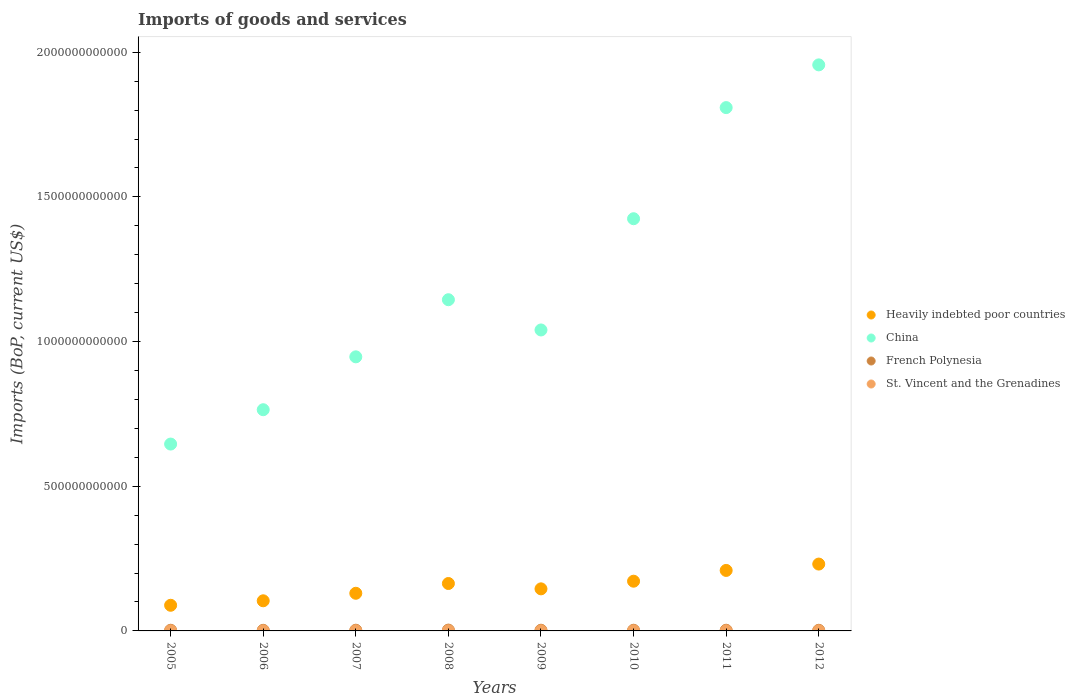What is the amount spent on imports in China in 2010?
Keep it short and to the point. 1.42e+12. Across all years, what is the maximum amount spent on imports in French Polynesia?
Offer a very short reply. 2.87e+09. Across all years, what is the minimum amount spent on imports in St. Vincent and the Grenadines?
Offer a very short reply. 2.91e+08. In which year was the amount spent on imports in China maximum?
Keep it short and to the point. 2012. What is the total amount spent on imports in St. Vincent and the Grenadines in the graph?
Ensure brevity in your answer.  3.01e+09. What is the difference between the amount spent on imports in St. Vincent and the Grenadines in 2009 and that in 2012?
Ensure brevity in your answer.  -1.41e+07. What is the difference between the amount spent on imports in China in 2006 and the amount spent on imports in St. Vincent and the Grenadines in 2012?
Provide a short and direct response. 7.64e+11. What is the average amount spent on imports in St. Vincent and the Grenadines per year?
Ensure brevity in your answer.  3.76e+08. In the year 2008, what is the difference between the amount spent on imports in Heavily indebted poor countries and amount spent on imports in China?
Your answer should be compact. -9.81e+11. What is the ratio of the amount spent on imports in China in 2005 to that in 2007?
Give a very brief answer. 0.68. What is the difference between the highest and the second highest amount spent on imports in China?
Keep it short and to the point. 1.48e+11. What is the difference between the highest and the lowest amount spent on imports in Heavily indebted poor countries?
Ensure brevity in your answer.  1.42e+11. In how many years, is the amount spent on imports in Heavily indebted poor countries greater than the average amount spent on imports in Heavily indebted poor countries taken over all years?
Offer a terse response. 4. Is the sum of the amount spent on imports in St. Vincent and the Grenadines in 2009 and 2012 greater than the maximum amount spent on imports in French Polynesia across all years?
Provide a succinct answer. No. Is it the case that in every year, the sum of the amount spent on imports in St. Vincent and the Grenadines and amount spent on imports in Heavily indebted poor countries  is greater than the sum of amount spent on imports in China and amount spent on imports in French Polynesia?
Keep it short and to the point. No. Is it the case that in every year, the sum of the amount spent on imports in St. Vincent and the Grenadines and amount spent on imports in Heavily indebted poor countries  is greater than the amount spent on imports in China?
Give a very brief answer. No. How many dotlines are there?
Keep it short and to the point. 4. How many years are there in the graph?
Provide a short and direct response. 8. What is the difference between two consecutive major ticks on the Y-axis?
Your response must be concise. 5.00e+11. Are the values on the major ticks of Y-axis written in scientific E-notation?
Give a very brief answer. No. Does the graph contain any zero values?
Your answer should be very brief. No. Does the graph contain grids?
Provide a succinct answer. No. Where does the legend appear in the graph?
Give a very brief answer. Center right. What is the title of the graph?
Your answer should be compact. Imports of goods and services. What is the label or title of the X-axis?
Provide a succinct answer. Years. What is the label or title of the Y-axis?
Your answer should be very brief. Imports (BoP, current US$). What is the Imports (BoP, current US$) of Heavily indebted poor countries in 2005?
Ensure brevity in your answer.  8.87e+1. What is the Imports (BoP, current US$) of China in 2005?
Provide a short and direct response. 6.46e+11. What is the Imports (BoP, current US$) in French Polynesia in 2005?
Your response must be concise. 2.31e+09. What is the Imports (BoP, current US$) of St. Vincent and the Grenadines in 2005?
Your answer should be compact. 2.91e+08. What is the Imports (BoP, current US$) of Heavily indebted poor countries in 2006?
Give a very brief answer. 1.04e+11. What is the Imports (BoP, current US$) in China in 2006?
Ensure brevity in your answer.  7.65e+11. What is the Imports (BoP, current US$) of French Polynesia in 2006?
Offer a terse response. 2.16e+09. What is the Imports (BoP, current US$) in St. Vincent and the Grenadines in 2006?
Provide a short and direct response. 3.26e+08. What is the Imports (BoP, current US$) in Heavily indebted poor countries in 2007?
Keep it short and to the point. 1.30e+11. What is the Imports (BoP, current US$) in China in 2007?
Your answer should be very brief. 9.47e+11. What is the Imports (BoP, current US$) of French Polynesia in 2007?
Offer a terse response. 2.43e+09. What is the Imports (BoP, current US$) in St. Vincent and the Grenadines in 2007?
Give a very brief answer. 4.02e+08. What is the Imports (BoP, current US$) in Heavily indebted poor countries in 2008?
Provide a succinct answer. 1.64e+11. What is the Imports (BoP, current US$) in China in 2008?
Your answer should be very brief. 1.14e+12. What is the Imports (BoP, current US$) of French Polynesia in 2008?
Provide a succinct answer. 2.87e+09. What is the Imports (BoP, current US$) of St. Vincent and the Grenadines in 2008?
Your response must be concise. 4.31e+08. What is the Imports (BoP, current US$) of Heavily indebted poor countries in 2009?
Provide a short and direct response. 1.45e+11. What is the Imports (BoP, current US$) in China in 2009?
Keep it short and to the point. 1.04e+12. What is the Imports (BoP, current US$) in French Polynesia in 2009?
Make the answer very short. 2.38e+09. What is the Imports (BoP, current US$) in St. Vincent and the Grenadines in 2009?
Offer a very short reply. 3.88e+08. What is the Imports (BoP, current US$) in Heavily indebted poor countries in 2010?
Keep it short and to the point. 1.72e+11. What is the Imports (BoP, current US$) of China in 2010?
Offer a terse response. 1.42e+12. What is the Imports (BoP, current US$) in French Polynesia in 2010?
Give a very brief answer. 2.33e+09. What is the Imports (BoP, current US$) of St. Vincent and the Grenadines in 2010?
Offer a terse response. 3.89e+08. What is the Imports (BoP, current US$) of Heavily indebted poor countries in 2011?
Make the answer very short. 2.09e+11. What is the Imports (BoP, current US$) of China in 2011?
Your answer should be very brief. 1.81e+12. What is the Imports (BoP, current US$) in French Polynesia in 2011?
Give a very brief answer. 2.34e+09. What is the Imports (BoP, current US$) in St. Vincent and the Grenadines in 2011?
Provide a succinct answer. 3.77e+08. What is the Imports (BoP, current US$) of Heavily indebted poor countries in 2012?
Your answer should be compact. 2.31e+11. What is the Imports (BoP, current US$) of China in 2012?
Make the answer very short. 1.96e+12. What is the Imports (BoP, current US$) of French Polynesia in 2012?
Your answer should be very brief. 2.20e+09. What is the Imports (BoP, current US$) in St. Vincent and the Grenadines in 2012?
Offer a very short reply. 4.02e+08. Across all years, what is the maximum Imports (BoP, current US$) of Heavily indebted poor countries?
Your response must be concise. 2.31e+11. Across all years, what is the maximum Imports (BoP, current US$) of China?
Your answer should be compact. 1.96e+12. Across all years, what is the maximum Imports (BoP, current US$) of French Polynesia?
Your answer should be very brief. 2.87e+09. Across all years, what is the maximum Imports (BoP, current US$) in St. Vincent and the Grenadines?
Keep it short and to the point. 4.31e+08. Across all years, what is the minimum Imports (BoP, current US$) of Heavily indebted poor countries?
Your response must be concise. 8.87e+1. Across all years, what is the minimum Imports (BoP, current US$) of China?
Your answer should be compact. 6.46e+11. Across all years, what is the minimum Imports (BoP, current US$) in French Polynesia?
Offer a very short reply. 2.16e+09. Across all years, what is the minimum Imports (BoP, current US$) of St. Vincent and the Grenadines?
Your response must be concise. 2.91e+08. What is the total Imports (BoP, current US$) in Heavily indebted poor countries in the graph?
Make the answer very short. 1.24e+12. What is the total Imports (BoP, current US$) of China in the graph?
Keep it short and to the point. 9.73e+12. What is the total Imports (BoP, current US$) in French Polynesia in the graph?
Ensure brevity in your answer.  1.90e+1. What is the total Imports (BoP, current US$) in St. Vincent and the Grenadines in the graph?
Your answer should be compact. 3.01e+09. What is the difference between the Imports (BoP, current US$) in Heavily indebted poor countries in 2005 and that in 2006?
Offer a very short reply. -1.55e+1. What is the difference between the Imports (BoP, current US$) in China in 2005 and that in 2006?
Your answer should be very brief. -1.19e+11. What is the difference between the Imports (BoP, current US$) in French Polynesia in 2005 and that in 2006?
Keep it short and to the point. 1.59e+08. What is the difference between the Imports (BoP, current US$) in St. Vincent and the Grenadines in 2005 and that in 2006?
Provide a short and direct response. -3.47e+07. What is the difference between the Imports (BoP, current US$) of Heavily indebted poor countries in 2005 and that in 2007?
Ensure brevity in your answer.  -4.14e+1. What is the difference between the Imports (BoP, current US$) in China in 2005 and that in 2007?
Provide a short and direct response. -3.01e+11. What is the difference between the Imports (BoP, current US$) of French Polynesia in 2005 and that in 2007?
Keep it short and to the point. -1.17e+08. What is the difference between the Imports (BoP, current US$) of St. Vincent and the Grenadines in 2005 and that in 2007?
Your answer should be very brief. -1.11e+08. What is the difference between the Imports (BoP, current US$) of Heavily indebted poor countries in 2005 and that in 2008?
Your response must be concise. -7.52e+1. What is the difference between the Imports (BoP, current US$) of China in 2005 and that in 2008?
Your answer should be compact. -4.99e+11. What is the difference between the Imports (BoP, current US$) of French Polynesia in 2005 and that in 2008?
Give a very brief answer. -5.50e+08. What is the difference between the Imports (BoP, current US$) in St. Vincent and the Grenadines in 2005 and that in 2008?
Offer a very short reply. -1.40e+08. What is the difference between the Imports (BoP, current US$) in Heavily indebted poor countries in 2005 and that in 2009?
Keep it short and to the point. -5.68e+1. What is the difference between the Imports (BoP, current US$) in China in 2005 and that in 2009?
Keep it short and to the point. -3.94e+11. What is the difference between the Imports (BoP, current US$) of French Polynesia in 2005 and that in 2009?
Your response must be concise. -6.25e+07. What is the difference between the Imports (BoP, current US$) of St. Vincent and the Grenadines in 2005 and that in 2009?
Keep it short and to the point. -9.69e+07. What is the difference between the Imports (BoP, current US$) in Heavily indebted poor countries in 2005 and that in 2010?
Your answer should be compact. -8.32e+1. What is the difference between the Imports (BoP, current US$) in China in 2005 and that in 2010?
Your answer should be very brief. -7.79e+11. What is the difference between the Imports (BoP, current US$) in French Polynesia in 2005 and that in 2010?
Make the answer very short. -1.53e+07. What is the difference between the Imports (BoP, current US$) of St. Vincent and the Grenadines in 2005 and that in 2010?
Offer a very short reply. -9.80e+07. What is the difference between the Imports (BoP, current US$) in Heavily indebted poor countries in 2005 and that in 2011?
Offer a terse response. -1.20e+11. What is the difference between the Imports (BoP, current US$) in China in 2005 and that in 2011?
Your response must be concise. -1.16e+12. What is the difference between the Imports (BoP, current US$) in French Polynesia in 2005 and that in 2011?
Your response must be concise. -2.05e+07. What is the difference between the Imports (BoP, current US$) in St. Vincent and the Grenadines in 2005 and that in 2011?
Offer a very short reply. -8.54e+07. What is the difference between the Imports (BoP, current US$) in Heavily indebted poor countries in 2005 and that in 2012?
Your answer should be very brief. -1.42e+11. What is the difference between the Imports (BoP, current US$) of China in 2005 and that in 2012?
Keep it short and to the point. -1.31e+12. What is the difference between the Imports (BoP, current US$) of French Polynesia in 2005 and that in 2012?
Offer a very short reply. 1.11e+08. What is the difference between the Imports (BoP, current US$) in St. Vincent and the Grenadines in 2005 and that in 2012?
Your answer should be compact. -1.11e+08. What is the difference between the Imports (BoP, current US$) in Heavily indebted poor countries in 2006 and that in 2007?
Ensure brevity in your answer.  -2.60e+1. What is the difference between the Imports (BoP, current US$) of China in 2006 and that in 2007?
Keep it short and to the point. -1.83e+11. What is the difference between the Imports (BoP, current US$) in French Polynesia in 2006 and that in 2007?
Provide a short and direct response. -2.76e+08. What is the difference between the Imports (BoP, current US$) in St. Vincent and the Grenadines in 2006 and that in 2007?
Ensure brevity in your answer.  -7.63e+07. What is the difference between the Imports (BoP, current US$) in Heavily indebted poor countries in 2006 and that in 2008?
Offer a terse response. -5.98e+1. What is the difference between the Imports (BoP, current US$) in China in 2006 and that in 2008?
Ensure brevity in your answer.  -3.80e+11. What is the difference between the Imports (BoP, current US$) in French Polynesia in 2006 and that in 2008?
Provide a succinct answer. -7.10e+08. What is the difference between the Imports (BoP, current US$) of St. Vincent and the Grenadines in 2006 and that in 2008?
Keep it short and to the point. -1.05e+08. What is the difference between the Imports (BoP, current US$) in Heavily indebted poor countries in 2006 and that in 2009?
Offer a terse response. -4.13e+1. What is the difference between the Imports (BoP, current US$) of China in 2006 and that in 2009?
Make the answer very short. -2.76e+11. What is the difference between the Imports (BoP, current US$) in French Polynesia in 2006 and that in 2009?
Ensure brevity in your answer.  -2.22e+08. What is the difference between the Imports (BoP, current US$) of St. Vincent and the Grenadines in 2006 and that in 2009?
Keep it short and to the point. -6.22e+07. What is the difference between the Imports (BoP, current US$) of Heavily indebted poor countries in 2006 and that in 2010?
Your answer should be very brief. -6.77e+1. What is the difference between the Imports (BoP, current US$) in China in 2006 and that in 2010?
Keep it short and to the point. -6.60e+11. What is the difference between the Imports (BoP, current US$) of French Polynesia in 2006 and that in 2010?
Your answer should be compact. -1.75e+08. What is the difference between the Imports (BoP, current US$) in St. Vincent and the Grenadines in 2006 and that in 2010?
Provide a short and direct response. -6.33e+07. What is the difference between the Imports (BoP, current US$) in Heavily indebted poor countries in 2006 and that in 2011?
Provide a succinct answer. -1.05e+11. What is the difference between the Imports (BoP, current US$) in China in 2006 and that in 2011?
Your answer should be compact. -1.04e+12. What is the difference between the Imports (BoP, current US$) in French Polynesia in 2006 and that in 2011?
Provide a short and direct response. -1.80e+08. What is the difference between the Imports (BoP, current US$) of St. Vincent and the Grenadines in 2006 and that in 2011?
Give a very brief answer. -5.08e+07. What is the difference between the Imports (BoP, current US$) of Heavily indebted poor countries in 2006 and that in 2012?
Your answer should be very brief. -1.27e+11. What is the difference between the Imports (BoP, current US$) of China in 2006 and that in 2012?
Make the answer very short. -1.19e+12. What is the difference between the Imports (BoP, current US$) in French Polynesia in 2006 and that in 2012?
Provide a succinct answer. -4.88e+07. What is the difference between the Imports (BoP, current US$) of St. Vincent and the Grenadines in 2006 and that in 2012?
Your answer should be very brief. -7.62e+07. What is the difference between the Imports (BoP, current US$) of Heavily indebted poor countries in 2007 and that in 2008?
Provide a short and direct response. -3.38e+1. What is the difference between the Imports (BoP, current US$) of China in 2007 and that in 2008?
Offer a very short reply. -1.97e+11. What is the difference between the Imports (BoP, current US$) of French Polynesia in 2007 and that in 2008?
Provide a short and direct response. -4.33e+08. What is the difference between the Imports (BoP, current US$) of St. Vincent and the Grenadines in 2007 and that in 2008?
Offer a terse response. -2.87e+07. What is the difference between the Imports (BoP, current US$) in Heavily indebted poor countries in 2007 and that in 2009?
Provide a succinct answer. -1.53e+1. What is the difference between the Imports (BoP, current US$) in China in 2007 and that in 2009?
Your answer should be very brief. -9.29e+1. What is the difference between the Imports (BoP, current US$) in French Polynesia in 2007 and that in 2009?
Give a very brief answer. 5.44e+07. What is the difference between the Imports (BoP, current US$) in St. Vincent and the Grenadines in 2007 and that in 2009?
Your answer should be very brief. 1.41e+07. What is the difference between the Imports (BoP, current US$) in Heavily indebted poor countries in 2007 and that in 2010?
Offer a terse response. -4.17e+1. What is the difference between the Imports (BoP, current US$) in China in 2007 and that in 2010?
Give a very brief answer. -4.77e+11. What is the difference between the Imports (BoP, current US$) of French Polynesia in 2007 and that in 2010?
Provide a short and direct response. 1.02e+08. What is the difference between the Imports (BoP, current US$) of St. Vincent and the Grenadines in 2007 and that in 2010?
Provide a succinct answer. 1.29e+07. What is the difference between the Imports (BoP, current US$) of Heavily indebted poor countries in 2007 and that in 2011?
Your answer should be very brief. -7.90e+1. What is the difference between the Imports (BoP, current US$) of China in 2007 and that in 2011?
Give a very brief answer. -8.61e+11. What is the difference between the Imports (BoP, current US$) in French Polynesia in 2007 and that in 2011?
Keep it short and to the point. 9.64e+07. What is the difference between the Imports (BoP, current US$) in St. Vincent and the Grenadines in 2007 and that in 2011?
Provide a short and direct response. 2.55e+07. What is the difference between the Imports (BoP, current US$) in Heavily indebted poor countries in 2007 and that in 2012?
Make the answer very short. -1.01e+11. What is the difference between the Imports (BoP, current US$) of China in 2007 and that in 2012?
Ensure brevity in your answer.  -1.01e+12. What is the difference between the Imports (BoP, current US$) of French Polynesia in 2007 and that in 2012?
Give a very brief answer. 2.27e+08. What is the difference between the Imports (BoP, current US$) of St. Vincent and the Grenadines in 2007 and that in 2012?
Offer a very short reply. 1.83e+04. What is the difference between the Imports (BoP, current US$) of Heavily indebted poor countries in 2008 and that in 2009?
Offer a terse response. 1.85e+1. What is the difference between the Imports (BoP, current US$) in China in 2008 and that in 2009?
Provide a short and direct response. 1.05e+11. What is the difference between the Imports (BoP, current US$) of French Polynesia in 2008 and that in 2009?
Offer a very short reply. 4.88e+08. What is the difference between the Imports (BoP, current US$) in St. Vincent and the Grenadines in 2008 and that in 2009?
Offer a terse response. 4.28e+07. What is the difference between the Imports (BoP, current US$) in Heavily indebted poor countries in 2008 and that in 2010?
Provide a short and direct response. -7.95e+09. What is the difference between the Imports (BoP, current US$) of China in 2008 and that in 2010?
Your answer should be very brief. -2.80e+11. What is the difference between the Imports (BoP, current US$) in French Polynesia in 2008 and that in 2010?
Make the answer very short. 5.35e+08. What is the difference between the Imports (BoP, current US$) in St. Vincent and the Grenadines in 2008 and that in 2010?
Offer a terse response. 4.16e+07. What is the difference between the Imports (BoP, current US$) in Heavily indebted poor countries in 2008 and that in 2011?
Give a very brief answer. -4.52e+1. What is the difference between the Imports (BoP, current US$) of China in 2008 and that in 2011?
Your answer should be compact. -6.64e+11. What is the difference between the Imports (BoP, current US$) in French Polynesia in 2008 and that in 2011?
Ensure brevity in your answer.  5.30e+08. What is the difference between the Imports (BoP, current US$) of St. Vincent and the Grenadines in 2008 and that in 2011?
Offer a very short reply. 5.42e+07. What is the difference between the Imports (BoP, current US$) in Heavily indebted poor countries in 2008 and that in 2012?
Provide a succinct answer. -6.72e+1. What is the difference between the Imports (BoP, current US$) in China in 2008 and that in 2012?
Make the answer very short. -8.12e+11. What is the difference between the Imports (BoP, current US$) in French Polynesia in 2008 and that in 2012?
Ensure brevity in your answer.  6.61e+08. What is the difference between the Imports (BoP, current US$) of St. Vincent and the Grenadines in 2008 and that in 2012?
Your answer should be compact. 2.87e+07. What is the difference between the Imports (BoP, current US$) of Heavily indebted poor countries in 2009 and that in 2010?
Provide a short and direct response. -2.64e+1. What is the difference between the Imports (BoP, current US$) in China in 2009 and that in 2010?
Ensure brevity in your answer.  -3.84e+11. What is the difference between the Imports (BoP, current US$) of French Polynesia in 2009 and that in 2010?
Offer a very short reply. 4.72e+07. What is the difference between the Imports (BoP, current US$) of St. Vincent and the Grenadines in 2009 and that in 2010?
Your answer should be compact. -1.13e+06. What is the difference between the Imports (BoP, current US$) in Heavily indebted poor countries in 2009 and that in 2011?
Provide a short and direct response. -6.37e+1. What is the difference between the Imports (BoP, current US$) in China in 2009 and that in 2011?
Ensure brevity in your answer.  -7.69e+11. What is the difference between the Imports (BoP, current US$) of French Polynesia in 2009 and that in 2011?
Make the answer very short. 4.20e+07. What is the difference between the Imports (BoP, current US$) in St. Vincent and the Grenadines in 2009 and that in 2011?
Give a very brief answer. 1.14e+07. What is the difference between the Imports (BoP, current US$) of Heavily indebted poor countries in 2009 and that in 2012?
Keep it short and to the point. -8.56e+1. What is the difference between the Imports (BoP, current US$) of China in 2009 and that in 2012?
Offer a terse response. -9.16e+11. What is the difference between the Imports (BoP, current US$) of French Polynesia in 2009 and that in 2012?
Your answer should be very brief. 1.73e+08. What is the difference between the Imports (BoP, current US$) in St. Vincent and the Grenadines in 2009 and that in 2012?
Your response must be concise. -1.41e+07. What is the difference between the Imports (BoP, current US$) in Heavily indebted poor countries in 2010 and that in 2011?
Your answer should be compact. -3.72e+1. What is the difference between the Imports (BoP, current US$) in China in 2010 and that in 2011?
Your answer should be very brief. -3.84e+11. What is the difference between the Imports (BoP, current US$) in French Polynesia in 2010 and that in 2011?
Your answer should be compact. -5.19e+06. What is the difference between the Imports (BoP, current US$) in St. Vincent and the Grenadines in 2010 and that in 2011?
Offer a very short reply. 1.26e+07. What is the difference between the Imports (BoP, current US$) of Heavily indebted poor countries in 2010 and that in 2012?
Make the answer very short. -5.92e+1. What is the difference between the Imports (BoP, current US$) in China in 2010 and that in 2012?
Your answer should be compact. -5.32e+11. What is the difference between the Imports (BoP, current US$) in French Polynesia in 2010 and that in 2012?
Your answer should be compact. 1.26e+08. What is the difference between the Imports (BoP, current US$) of St. Vincent and the Grenadines in 2010 and that in 2012?
Offer a terse response. -1.29e+07. What is the difference between the Imports (BoP, current US$) in Heavily indebted poor countries in 2011 and that in 2012?
Your answer should be compact. -2.20e+1. What is the difference between the Imports (BoP, current US$) in China in 2011 and that in 2012?
Give a very brief answer. -1.48e+11. What is the difference between the Imports (BoP, current US$) of French Polynesia in 2011 and that in 2012?
Offer a very short reply. 1.31e+08. What is the difference between the Imports (BoP, current US$) in St. Vincent and the Grenadines in 2011 and that in 2012?
Your answer should be very brief. -2.55e+07. What is the difference between the Imports (BoP, current US$) in Heavily indebted poor countries in 2005 and the Imports (BoP, current US$) in China in 2006?
Keep it short and to the point. -6.76e+11. What is the difference between the Imports (BoP, current US$) of Heavily indebted poor countries in 2005 and the Imports (BoP, current US$) of French Polynesia in 2006?
Keep it short and to the point. 8.65e+1. What is the difference between the Imports (BoP, current US$) of Heavily indebted poor countries in 2005 and the Imports (BoP, current US$) of St. Vincent and the Grenadines in 2006?
Your answer should be very brief. 8.83e+1. What is the difference between the Imports (BoP, current US$) of China in 2005 and the Imports (BoP, current US$) of French Polynesia in 2006?
Offer a terse response. 6.44e+11. What is the difference between the Imports (BoP, current US$) of China in 2005 and the Imports (BoP, current US$) of St. Vincent and the Grenadines in 2006?
Provide a succinct answer. 6.46e+11. What is the difference between the Imports (BoP, current US$) in French Polynesia in 2005 and the Imports (BoP, current US$) in St. Vincent and the Grenadines in 2006?
Give a very brief answer. 1.99e+09. What is the difference between the Imports (BoP, current US$) in Heavily indebted poor countries in 2005 and the Imports (BoP, current US$) in China in 2007?
Your answer should be very brief. -8.59e+11. What is the difference between the Imports (BoP, current US$) of Heavily indebted poor countries in 2005 and the Imports (BoP, current US$) of French Polynesia in 2007?
Offer a terse response. 8.62e+1. What is the difference between the Imports (BoP, current US$) of Heavily indebted poor countries in 2005 and the Imports (BoP, current US$) of St. Vincent and the Grenadines in 2007?
Ensure brevity in your answer.  8.82e+1. What is the difference between the Imports (BoP, current US$) of China in 2005 and the Imports (BoP, current US$) of French Polynesia in 2007?
Your response must be concise. 6.43e+11. What is the difference between the Imports (BoP, current US$) of China in 2005 and the Imports (BoP, current US$) of St. Vincent and the Grenadines in 2007?
Make the answer very short. 6.45e+11. What is the difference between the Imports (BoP, current US$) in French Polynesia in 2005 and the Imports (BoP, current US$) in St. Vincent and the Grenadines in 2007?
Offer a very short reply. 1.91e+09. What is the difference between the Imports (BoP, current US$) in Heavily indebted poor countries in 2005 and the Imports (BoP, current US$) in China in 2008?
Provide a short and direct response. -1.06e+12. What is the difference between the Imports (BoP, current US$) of Heavily indebted poor countries in 2005 and the Imports (BoP, current US$) of French Polynesia in 2008?
Offer a terse response. 8.58e+1. What is the difference between the Imports (BoP, current US$) of Heavily indebted poor countries in 2005 and the Imports (BoP, current US$) of St. Vincent and the Grenadines in 2008?
Your answer should be compact. 8.82e+1. What is the difference between the Imports (BoP, current US$) in China in 2005 and the Imports (BoP, current US$) in French Polynesia in 2008?
Provide a short and direct response. 6.43e+11. What is the difference between the Imports (BoP, current US$) in China in 2005 and the Imports (BoP, current US$) in St. Vincent and the Grenadines in 2008?
Ensure brevity in your answer.  6.45e+11. What is the difference between the Imports (BoP, current US$) in French Polynesia in 2005 and the Imports (BoP, current US$) in St. Vincent and the Grenadines in 2008?
Offer a very short reply. 1.88e+09. What is the difference between the Imports (BoP, current US$) in Heavily indebted poor countries in 2005 and the Imports (BoP, current US$) in China in 2009?
Your answer should be compact. -9.52e+11. What is the difference between the Imports (BoP, current US$) of Heavily indebted poor countries in 2005 and the Imports (BoP, current US$) of French Polynesia in 2009?
Give a very brief answer. 8.63e+1. What is the difference between the Imports (BoP, current US$) in Heavily indebted poor countries in 2005 and the Imports (BoP, current US$) in St. Vincent and the Grenadines in 2009?
Keep it short and to the point. 8.83e+1. What is the difference between the Imports (BoP, current US$) of China in 2005 and the Imports (BoP, current US$) of French Polynesia in 2009?
Make the answer very short. 6.43e+11. What is the difference between the Imports (BoP, current US$) in China in 2005 and the Imports (BoP, current US$) in St. Vincent and the Grenadines in 2009?
Give a very brief answer. 6.45e+11. What is the difference between the Imports (BoP, current US$) of French Polynesia in 2005 and the Imports (BoP, current US$) of St. Vincent and the Grenadines in 2009?
Offer a very short reply. 1.93e+09. What is the difference between the Imports (BoP, current US$) of Heavily indebted poor countries in 2005 and the Imports (BoP, current US$) of China in 2010?
Ensure brevity in your answer.  -1.34e+12. What is the difference between the Imports (BoP, current US$) of Heavily indebted poor countries in 2005 and the Imports (BoP, current US$) of French Polynesia in 2010?
Your response must be concise. 8.63e+1. What is the difference between the Imports (BoP, current US$) in Heavily indebted poor countries in 2005 and the Imports (BoP, current US$) in St. Vincent and the Grenadines in 2010?
Make the answer very short. 8.83e+1. What is the difference between the Imports (BoP, current US$) of China in 2005 and the Imports (BoP, current US$) of French Polynesia in 2010?
Your response must be concise. 6.44e+11. What is the difference between the Imports (BoP, current US$) in China in 2005 and the Imports (BoP, current US$) in St. Vincent and the Grenadines in 2010?
Provide a short and direct response. 6.45e+11. What is the difference between the Imports (BoP, current US$) in French Polynesia in 2005 and the Imports (BoP, current US$) in St. Vincent and the Grenadines in 2010?
Ensure brevity in your answer.  1.93e+09. What is the difference between the Imports (BoP, current US$) in Heavily indebted poor countries in 2005 and the Imports (BoP, current US$) in China in 2011?
Give a very brief answer. -1.72e+12. What is the difference between the Imports (BoP, current US$) of Heavily indebted poor countries in 2005 and the Imports (BoP, current US$) of French Polynesia in 2011?
Offer a very short reply. 8.63e+1. What is the difference between the Imports (BoP, current US$) in Heavily indebted poor countries in 2005 and the Imports (BoP, current US$) in St. Vincent and the Grenadines in 2011?
Give a very brief answer. 8.83e+1. What is the difference between the Imports (BoP, current US$) in China in 2005 and the Imports (BoP, current US$) in French Polynesia in 2011?
Your answer should be very brief. 6.43e+11. What is the difference between the Imports (BoP, current US$) of China in 2005 and the Imports (BoP, current US$) of St. Vincent and the Grenadines in 2011?
Offer a very short reply. 6.45e+11. What is the difference between the Imports (BoP, current US$) of French Polynesia in 2005 and the Imports (BoP, current US$) of St. Vincent and the Grenadines in 2011?
Your answer should be compact. 1.94e+09. What is the difference between the Imports (BoP, current US$) of Heavily indebted poor countries in 2005 and the Imports (BoP, current US$) of China in 2012?
Your answer should be very brief. -1.87e+12. What is the difference between the Imports (BoP, current US$) in Heavily indebted poor countries in 2005 and the Imports (BoP, current US$) in French Polynesia in 2012?
Provide a succinct answer. 8.64e+1. What is the difference between the Imports (BoP, current US$) of Heavily indebted poor countries in 2005 and the Imports (BoP, current US$) of St. Vincent and the Grenadines in 2012?
Offer a very short reply. 8.82e+1. What is the difference between the Imports (BoP, current US$) of China in 2005 and the Imports (BoP, current US$) of French Polynesia in 2012?
Your answer should be very brief. 6.44e+11. What is the difference between the Imports (BoP, current US$) in China in 2005 and the Imports (BoP, current US$) in St. Vincent and the Grenadines in 2012?
Your response must be concise. 6.45e+11. What is the difference between the Imports (BoP, current US$) of French Polynesia in 2005 and the Imports (BoP, current US$) of St. Vincent and the Grenadines in 2012?
Offer a terse response. 1.91e+09. What is the difference between the Imports (BoP, current US$) of Heavily indebted poor countries in 2006 and the Imports (BoP, current US$) of China in 2007?
Make the answer very short. -8.43e+11. What is the difference between the Imports (BoP, current US$) of Heavily indebted poor countries in 2006 and the Imports (BoP, current US$) of French Polynesia in 2007?
Make the answer very short. 1.02e+11. What is the difference between the Imports (BoP, current US$) of Heavily indebted poor countries in 2006 and the Imports (BoP, current US$) of St. Vincent and the Grenadines in 2007?
Ensure brevity in your answer.  1.04e+11. What is the difference between the Imports (BoP, current US$) of China in 2006 and the Imports (BoP, current US$) of French Polynesia in 2007?
Offer a very short reply. 7.62e+11. What is the difference between the Imports (BoP, current US$) of China in 2006 and the Imports (BoP, current US$) of St. Vincent and the Grenadines in 2007?
Provide a succinct answer. 7.64e+11. What is the difference between the Imports (BoP, current US$) in French Polynesia in 2006 and the Imports (BoP, current US$) in St. Vincent and the Grenadines in 2007?
Offer a very short reply. 1.75e+09. What is the difference between the Imports (BoP, current US$) in Heavily indebted poor countries in 2006 and the Imports (BoP, current US$) in China in 2008?
Your answer should be compact. -1.04e+12. What is the difference between the Imports (BoP, current US$) in Heavily indebted poor countries in 2006 and the Imports (BoP, current US$) in French Polynesia in 2008?
Make the answer very short. 1.01e+11. What is the difference between the Imports (BoP, current US$) in Heavily indebted poor countries in 2006 and the Imports (BoP, current US$) in St. Vincent and the Grenadines in 2008?
Your answer should be very brief. 1.04e+11. What is the difference between the Imports (BoP, current US$) of China in 2006 and the Imports (BoP, current US$) of French Polynesia in 2008?
Your response must be concise. 7.62e+11. What is the difference between the Imports (BoP, current US$) in China in 2006 and the Imports (BoP, current US$) in St. Vincent and the Grenadines in 2008?
Keep it short and to the point. 7.64e+11. What is the difference between the Imports (BoP, current US$) of French Polynesia in 2006 and the Imports (BoP, current US$) of St. Vincent and the Grenadines in 2008?
Provide a succinct answer. 1.72e+09. What is the difference between the Imports (BoP, current US$) in Heavily indebted poor countries in 2006 and the Imports (BoP, current US$) in China in 2009?
Your answer should be very brief. -9.36e+11. What is the difference between the Imports (BoP, current US$) in Heavily indebted poor countries in 2006 and the Imports (BoP, current US$) in French Polynesia in 2009?
Provide a succinct answer. 1.02e+11. What is the difference between the Imports (BoP, current US$) in Heavily indebted poor countries in 2006 and the Imports (BoP, current US$) in St. Vincent and the Grenadines in 2009?
Your answer should be compact. 1.04e+11. What is the difference between the Imports (BoP, current US$) of China in 2006 and the Imports (BoP, current US$) of French Polynesia in 2009?
Your answer should be compact. 7.62e+11. What is the difference between the Imports (BoP, current US$) in China in 2006 and the Imports (BoP, current US$) in St. Vincent and the Grenadines in 2009?
Ensure brevity in your answer.  7.64e+11. What is the difference between the Imports (BoP, current US$) of French Polynesia in 2006 and the Imports (BoP, current US$) of St. Vincent and the Grenadines in 2009?
Give a very brief answer. 1.77e+09. What is the difference between the Imports (BoP, current US$) in Heavily indebted poor countries in 2006 and the Imports (BoP, current US$) in China in 2010?
Your answer should be compact. -1.32e+12. What is the difference between the Imports (BoP, current US$) of Heavily indebted poor countries in 2006 and the Imports (BoP, current US$) of French Polynesia in 2010?
Offer a terse response. 1.02e+11. What is the difference between the Imports (BoP, current US$) in Heavily indebted poor countries in 2006 and the Imports (BoP, current US$) in St. Vincent and the Grenadines in 2010?
Your answer should be very brief. 1.04e+11. What is the difference between the Imports (BoP, current US$) of China in 2006 and the Imports (BoP, current US$) of French Polynesia in 2010?
Keep it short and to the point. 7.62e+11. What is the difference between the Imports (BoP, current US$) in China in 2006 and the Imports (BoP, current US$) in St. Vincent and the Grenadines in 2010?
Provide a short and direct response. 7.64e+11. What is the difference between the Imports (BoP, current US$) in French Polynesia in 2006 and the Imports (BoP, current US$) in St. Vincent and the Grenadines in 2010?
Your answer should be compact. 1.77e+09. What is the difference between the Imports (BoP, current US$) in Heavily indebted poor countries in 2006 and the Imports (BoP, current US$) in China in 2011?
Make the answer very short. -1.70e+12. What is the difference between the Imports (BoP, current US$) in Heavily indebted poor countries in 2006 and the Imports (BoP, current US$) in French Polynesia in 2011?
Keep it short and to the point. 1.02e+11. What is the difference between the Imports (BoP, current US$) in Heavily indebted poor countries in 2006 and the Imports (BoP, current US$) in St. Vincent and the Grenadines in 2011?
Keep it short and to the point. 1.04e+11. What is the difference between the Imports (BoP, current US$) in China in 2006 and the Imports (BoP, current US$) in French Polynesia in 2011?
Provide a succinct answer. 7.62e+11. What is the difference between the Imports (BoP, current US$) of China in 2006 and the Imports (BoP, current US$) of St. Vincent and the Grenadines in 2011?
Your answer should be compact. 7.64e+11. What is the difference between the Imports (BoP, current US$) in French Polynesia in 2006 and the Imports (BoP, current US$) in St. Vincent and the Grenadines in 2011?
Give a very brief answer. 1.78e+09. What is the difference between the Imports (BoP, current US$) of Heavily indebted poor countries in 2006 and the Imports (BoP, current US$) of China in 2012?
Your response must be concise. -1.85e+12. What is the difference between the Imports (BoP, current US$) of Heavily indebted poor countries in 2006 and the Imports (BoP, current US$) of French Polynesia in 2012?
Your response must be concise. 1.02e+11. What is the difference between the Imports (BoP, current US$) of Heavily indebted poor countries in 2006 and the Imports (BoP, current US$) of St. Vincent and the Grenadines in 2012?
Offer a terse response. 1.04e+11. What is the difference between the Imports (BoP, current US$) of China in 2006 and the Imports (BoP, current US$) of French Polynesia in 2012?
Provide a short and direct response. 7.62e+11. What is the difference between the Imports (BoP, current US$) of China in 2006 and the Imports (BoP, current US$) of St. Vincent and the Grenadines in 2012?
Keep it short and to the point. 7.64e+11. What is the difference between the Imports (BoP, current US$) in French Polynesia in 2006 and the Imports (BoP, current US$) in St. Vincent and the Grenadines in 2012?
Your response must be concise. 1.75e+09. What is the difference between the Imports (BoP, current US$) of Heavily indebted poor countries in 2007 and the Imports (BoP, current US$) of China in 2008?
Your answer should be very brief. -1.01e+12. What is the difference between the Imports (BoP, current US$) in Heavily indebted poor countries in 2007 and the Imports (BoP, current US$) in French Polynesia in 2008?
Give a very brief answer. 1.27e+11. What is the difference between the Imports (BoP, current US$) of Heavily indebted poor countries in 2007 and the Imports (BoP, current US$) of St. Vincent and the Grenadines in 2008?
Keep it short and to the point. 1.30e+11. What is the difference between the Imports (BoP, current US$) of China in 2007 and the Imports (BoP, current US$) of French Polynesia in 2008?
Give a very brief answer. 9.44e+11. What is the difference between the Imports (BoP, current US$) of China in 2007 and the Imports (BoP, current US$) of St. Vincent and the Grenadines in 2008?
Make the answer very short. 9.47e+11. What is the difference between the Imports (BoP, current US$) in French Polynesia in 2007 and the Imports (BoP, current US$) in St. Vincent and the Grenadines in 2008?
Provide a succinct answer. 2.00e+09. What is the difference between the Imports (BoP, current US$) in Heavily indebted poor countries in 2007 and the Imports (BoP, current US$) in China in 2009?
Ensure brevity in your answer.  -9.10e+11. What is the difference between the Imports (BoP, current US$) in Heavily indebted poor countries in 2007 and the Imports (BoP, current US$) in French Polynesia in 2009?
Offer a very short reply. 1.28e+11. What is the difference between the Imports (BoP, current US$) of Heavily indebted poor countries in 2007 and the Imports (BoP, current US$) of St. Vincent and the Grenadines in 2009?
Provide a short and direct response. 1.30e+11. What is the difference between the Imports (BoP, current US$) of China in 2007 and the Imports (BoP, current US$) of French Polynesia in 2009?
Give a very brief answer. 9.45e+11. What is the difference between the Imports (BoP, current US$) in China in 2007 and the Imports (BoP, current US$) in St. Vincent and the Grenadines in 2009?
Make the answer very short. 9.47e+11. What is the difference between the Imports (BoP, current US$) in French Polynesia in 2007 and the Imports (BoP, current US$) in St. Vincent and the Grenadines in 2009?
Make the answer very short. 2.04e+09. What is the difference between the Imports (BoP, current US$) of Heavily indebted poor countries in 2007 and the Imports (BoP, current US$) of China in 2010?
Ensure brevity in your answer.  -1.29e+12. What is the difference between the Imports (BoP, current US$) of Heavily indebted poor countries in 2007 and the Imports (BoP, current US$) of French Polynesia in 2010?
Your response must be concise. 1.28e+11. What is the difference between the Imports (BoP, current US$) of Heavily indebted poor countries in 2007 and the Imports (BoP, current US$) of St. Vincent and the Grenadines in 2010?
Your response must be concise. 1.30e+11. What is the difference between the Imports (BoP, current US$) in China in 2007 and the Imports (BoP, current US$) in French Polynesia in 2010?
Provide a succinct answer. 9.45e+11. What is the difference between the Imports (BoP, current US$) of China in 2007 and the Imports (BoP, current US$) of St. Vincent and the Grenadines in 2010?
Provide a succinct answer. 9.47e+11. What is the difference between the Imports (BoP, current US$) of French Polynesia in 2007 and the Imports (BoP, current US$) of St. Vincent and the Grenadines in 2010?
Offer a terse response. 2.04e+09. What is the difference between the Imports (BoP, current US$) in Heavily indebted poor countries in 2007 and the Imports (BoP, current US$) in China in 2011?
Ensure brevity in your answer.  -1.68e+12. What is the difference between the Imports (BoP, current US$) of Heavily indebted poor countries in 2007 and the Imports (BoP, current US$) of French Polynesia in 2011?
Your answer should be compact. 1.28e+11. What is the difference between the Imports (BoP, current US$) in Heavily indebted poor countries in 2007 and the Imports (BoP, current US$) in St. Vincent and the Grenadines in 2011?
Your answer should be compact. 1.30e+11. What is the difference between the Imports (BoP, current US$) of China in 2007 and the Imports (BoP, current US$) of French Polynesia in 2011?
Your answer should be very brief. 9.45e+11. What is the difference between the Imports (BoP, current US$) of China in 2007 and the Imports (BoP, current US$) of St. Vincent and the Grenadines in 2011?
Offer a very short reply. 9.47e+11. What is the difference between the Imports (BoP, current US$) in French Polynesia in 2007 and the Imports (BoP, current US$) in St. Vincent and the Grenadines in 2011?
Provide a short and direct response. 2.06e+09. What is the difference between the Imports (BoP, current US$) of Heavily indebted poor countries in 2007 and the Imports (BoP, current US$) of China in 2012?
Offer a terse response. -1.83e+12. What is the difference between the Imports (BoP, current US$) in Heavily indebted poor countries in 2007 and the Imports (BoP, current US$) in French Polynesia in 2012?
Make the answer very short. 1.28e+11. What is the difference between the Imports (BoP, current US$) in Heavily indebted poor countries in 2007 and the Imports (BoP, current US$) in St. Vincent and the Grenadines in 2012?
Your answer should be very brief. 1.30e+11. What is the difference between the Imports (BoP, current US$) of China in 2007 and the Imports (BoP, current US$) of French Polynesia in 2012?
Give a very brief answer. 9.45e+11. What is the difference between the Imports (BoP, current US$) of China in 2007 and the Imports (BoP, current US$) of St. Vincent and the Grenadines in 2012?
Your answer should be compact. 9.47e+11. What is the difference between the Imports (BoP, current US$) of French Polynesia in 2007 and the Imports (BoP, current US$) of St. Vincent and the Grenadines in 2012?
Provide a short and direct response. 2.03e+09. What is the difference between the Imports (BoP, current US$) in Heavily indebted poor countries in 2008 and the Imports (BoP, current US$) in China in 2009?
Provide a succinct answer. -8.76e+11. What is the difference between the Imports (BoP, current US$) in Heavily indebted poor countries in 2008 and the Imports (BoP, current US$) in French Polynesia in 2009?
Make the answer very short. 1.62e+11. What is the difference between the Imports (BoP, current US$) in Heavily indebted poor countries in 2008 and the Imports (BoP, current US$) in St. Vincent and the Grenadines in 2009?
Your answer should be compact. 1.64e+11. What is the difference between the Imports (BoP, current US$) of China in 2008 and the Imports (BoP, current US$) of French Polynesia in 2009?
Ensure brevity in your answer.  1.14e+12. What is the difference between the Imports (BoP, current US$) of China in 2008 and the Imports (BoP, current US$) of St. Vincent and the Grenadines in 2009?
Offer a very short reply. 1.14e+12. What is the difference between the Imports (BoP, current US$) of French Polynesia in 2008 and the Imports (BoP, current US$) of St. Vincent and the Grenadines in 2009?
Keep it short and to the point. 2.48e+09. What is the difference between the Imports (BoP, current US$) of Heavily indebted poor countries in 2008 and the Imports (BoP, current US$) of China in 2010?
Your answer should be very brief. -1.26e+12. What is the difference between the Imports (BoP, current US$) in Heavily indebted poor countries in 2008 and the Imports (BoP, current US$) in French Polynesia in 2010?
Keep it short and to the point. 1.62e+11. What is the difference between the Imports (BoP, current US$) in Heavily indebted poor countries in 2008 and the Imports (BoP, current US$) in St. Vincent and the Grenadines in 2010?
Your response must be concise. 1.64e+11. What is the difference between the Imports (BoP, current US$) in China in 2008 and the Imports (BoP, current US$) in French Polynesia in 2010?
Offer a very short reply. 1.14e+12. What is the difference between the Imports (BoP, current US$) of China in 2008 and the Imports (BoP, current US$) of St. Vincent and the Grenadines in 2010?
Offer a very short reply. 1.14e+12. What is the difference between the Imports (BoP, current US$) of French Polynesia in 2008 and the Imports (BoP, current US$) of St. Vincent and the Grenadines in 2010?
Give a very brief answer. 2.48e+09. What is the difference between the Imports (BoP, current US$) in Heavily indebted poor countries in 2008 and the Imports (BoP, current US$) in China in 2011?
Your answer should be very brief. -1.64e+12. What is the difference between the Imports (BoP, current US$) of Heavily indebted poor countries in 2008 and the Imports (BoP, current US$) of French Polynesia in 2011?
Your answer should be very brief. 1.62e+11. What is the difference between the Imports (BoP, current US$) of Heavily indebted poor countries in 2008 and the Imports (BoP, current US$) of St. Vincent and the Grenadines in 2011?
Ensure brevity in your answer.  1.64e+11. What is the difference between the Imports (BoP, current US$) in China in 2008 and the Imports (BoP, current US$) in French Polynesia in 2011?
Offer a terse response. 1.14e+12. What is the difference between the Imports (BoP, current US$) in China in 2008 and the Imports (BoP, current US$) in St. Vincent and the Grenadines in 2011?
Your answer should be very brief. 1.14e+12. What is the difference between the Imports (BoP, current US$) in French Polynesia in 2008 and the Imports (BoP, current US$) in St. Vincent and the Grenadines in 2011?
Give a very brief answer. 2.49e+09. What is the difference between the Imports (BoP, current US$) of Heavily indebted poor countries in 2008 and the Imports (BoP, current US$) of China in 2012?
Keep it short and to the point. -1.79e+12. What is the difference between the Imports (BoP, current US$) in Heavily indebted poor countries in 2008 and the Imports (BoP, current US$) in French Polynesia in 2012?
Your response must be concise. 1.62e+11. What is the difference between the Imports (BoP, current US$) in Heavily indebted poor countries in 2008 and the Imports (BoP, current US$) in St. Vincent and the Grenadines in 2012?
Make the answer very short. 1.63e+11. What is the difference between the Imports (BoP, current US$) of China in 2008 and the Imports (BoP, current US$) of French Polynesia in 2012?
Give a very brief answer. 1.14e+12. What is the difference between the Imports (BoP, current US$) of China in 2008 and the Imports (BoP, current US$) of St. Vincent and the Grenadines in 2012?
Your response must be concise. 1.14e+12. What is the difference between the Imports (BoP, current US$) of French Polynesia in 2008 and the Imports (BoP, current US$) of St. Vincent and the Grenadines in 2012?
Make the answer very short. 2.46e+09. What is the difference between the Imports (BoP, current US$) in Heavily indebted poor countries in 2009 and the Imports (BoP, current US$) in China in 2010?
Keep it short and to the point. -1.28e+12. What is the difference between the Imports (BoP, current US$) of Heavily indebted poor countries in 2009 and the Imports (BoP, current US$) of French Polynesia in 2010?
Keep it short and to the point. 1.43e+11. What is the difference between the Imports (BoP, current US$) in Heavily indebted poor countries in 2009 and the Imports (BoP, current US$) in St. Vincent and the Grenadines in 2010?
Offer a very short reply. 1.45e+11. What is the difference between the Imports (BoP, current US$) in China in 2009 and the Imports (BoP, current US$) in French Polynesia in 2010?
Keep it short and to the point. 1.04e+12. What is the difference between the Imports (BoP, current US$) of China in 2009 and the Imports (BoP, current US$) of St. Vincent and the Grenadines in 2010?
Make the answer very short. 1.04e+12. What is the difference between the Imports (BoP, current US$) of French Polynesia in 2009 and the Imports (BoP, current US$) of St. Vincent and the Grenadines in 2010?
Your answer should be compact. 1.99e+09. What is the difference between the Imports (BoP, current US$) of Heavily indebted poor countries in 2009 and the Imports (BoP, current US$) of China in 2011?
Provide a short and direct response. -1.66e+12. What is the difference between the Imports (BoP, current US$) in Heavily indebted poor countries in 2009 and the Imports (BoP, current US$) in French Polynesia in 2011?
Offer a terse response. 1.43e+11. What is the difference between the Imports (BoP, current US$) of Heavily indebted poor countries in 2009 and the Imports (BoP, current US$) of St. Vincent and the Grenadines in 2011?
Provide a succinct answer. 1.45e+11. What is the difference between the Imports (BoP, current US$) in China in 2009 and the Imports (BoP, current US$) in French Polynesia in 2011?
Ensure brevity in your answer.  1.04e+12. What is the difference between the Imports (BoP, current US$) of China in 2009 and the Imports (BoP, current US$) of St. Vincent and the Grenadines in 2011?
Your response must be concise. 1.04e+12. What is the difference between the Imports (BoP, current US$) of French Polynesia in 2009 and the Imports (BoP, current US$) of St. Vincent and the Grenadines in 2011?
Make the answer very short. 2.00e+09. What is the difference between the Imports (BoP, current US$) of Heavily indebted poor countries in 2009 and the Imports (BoP, current US$) of China in 2012?
Offer a very short reply. -1.81e+12. What is the difference between the Imports (BoP, current US$) of Heavily indebted poor countries in 2009 and the Imports (BoP, current US$) of French Polynesia in 2012?
Give a very brief answer. 1.43e+11. What is the difference between the Imports (BoP, current US$) of Heavily indebted poor countries in 2009 and the Imports (BoP, current US$) of St. Vincent and the Grenadines in 2012?
Give a very brief answer. 1.45e+11. What is the difference between the Imports (BoP, current US$) in China in 2009 and the Imports (BoP, current US$) in French Polynesia in 2012?
Your answer should be compact. 1.04e+12. What is the difference between the Imports (BoP, current US$) of China in 2009 and the Imports (BoP, current US$) of St. Vincent and the Grenadines in 2012?
Give a very brief answer. 1.04e+12. What is the difference between the Imports (BoP, current US$) of French Polynesia in 2009 and the Imports (BoP, current US$) of St. Vincent and the Grenadines in 2012?
Keep it short and to the point. 1.98e+09. What is the difference between the Imports (BoP, current US$) of Heavily indebted poor countries in 2010 and the Imports (BoP, current US$) of China in 2011?
Your response must be concise. -1.64e+12. What is the difference between the Imports (BoP, current US$) in Heavily indebted poor countries in 2010 and the Imports (BoP, current US$) in French Polynesia in 2011?
Make the answer very short. 1.70e+11. What is the difference between the Imports (BoP, current US$) in Heavily indebted poor countries in 2010 and the Imports (BoP, current US$) in St. Vincent and the Grenadines in 2011?
Offer a terse response. 1.71e+11. What is the difference between the Imports (BoP, current US$) in China in 2010 and the Imports (BoP, current US$) in French Polynesia in 2011?
Provide a succinct answer. 1.42e+12. What is the difference between the Imports (BoP, current US$) of China in 2010 and the Imports (BoP, current US$) of St. Vincent and the Grenadines in 2011?
Offer a terse response. 1.42e+12. What is the difference between the Imports (BoP, current US$) of French Polynesia in 2010 and the Imports (BoP, current US$) of St. Vincent and the Grenadines in 2011?
Your answer should be very brief. 1.95e+09. What is the difference between the Imports (BoP, current US$) in Heavily indebted poor countries in 2010 and the Imports (BoP, current US$) in China in 2012?
Your response must be concise. -1.78e+12. What is the difference between the Imports (BoP, current US$) of Heavily indebted poor countries in 2010 and the Imports (BoP, current US$) of French Polynesia in 2012?
Your response must be concise. 1.70e+11. What is the difference between the Imports (BoP, current US$) of Heavily indebted poor countries in 2010 and the Imports (BoP, current US$) of St. Vincent and the Grenadines in 2012?
Make the answer very short. 1.71e+11. What is the difference between the Imports (BoP, current US$) in China in 2010 and the Imports (BoP, current US$) in French Polynesia in 2012?
Provide a succinct answer. 1.42e+12. What is the difference between the Imports (BoP, current US$) of China in 2010 and the Imports (BoP, current US$) of St. Vincent and the Grenadines in 2012?
Ensure brevity in your answer.  1.42e+12. What is the difference between the Imports (BoP, current US$) in French Polynesia in 2010 and the Imports (BoP, current US$) in St. Vincent and the Grenadines in 2012?
Provide a short and direct response. 1.93e+09. What is the difference between the Imports (BoP, current US$) in Heavily indebted poor countries in 2011 and the Imports (BoP, current US$) in China in 2012?
Your response must be concise. -1.75e+12. What is the difference between the Imports (BoP, current US$) in Heavily indebted poor countries in 2011 and the Imports (BoP, current US$) in French Polynesia in 2012?
Make the answer very short. 2.07e+11. What is the difference between the Imports (BoP, current US$) of Heavily indebted poor countries in 2011 and the Imports (BoP, current US$) of St. Vincent and the Grenadines in 2012?
Your answer should be compact. 2.09e+11. What is the difference between the Imports (BoP, current US$) in China in 2011 and the Imports (BoP, current US$) in French Polynesia in 2012?
Offer a terse response. 1.81e+12. What is the difference between the Imports (BoP, current US$) in China in 2011 and the Imports (BoP, current US$) in St. Vincent and the Grenadines in 2012?
Your response must be concise. 1.81e+12. What is the difference between the Imports (BoP, current US$) of French Polynesia in 2011 and the Imports (BoP, current US$) of St. Vincent and the Grenadines in 2012?
Provide a short and direct response. 1.93e+09. What is the average Imports (BoP, current US$) in Heavily indebted poor countries per year?
Your answer should be compact. 1.56e+11. What is the average Imports (BoP, current US$) in China per year?
Offer a very short reply. 1.22e+12. What is the average Imports (BoP, current US$) in French Polynesia per year?
Your response must be concise. 2.38e+09. What is the average Imports (BoP, current US$) of St. Vincent and the Grenadines per year?
Your answer should be compact. 3.76e+08. In the year 2005, what is the difference between the Imports (BoP, current US$) of Heavily indebted poor countries and Imports (BoP, current US$) of China?
Offer a very short reply. -5.57e+11. In the year 2005, what is the difference between the Imports (BoP, current US$) of Heavily indebted poor countries and Imports (BoP, current US$) of French Polynesia?
Your answer should be very brief. 8.63e+1. In the year 2005, what is the difference between the Imports (BoP, current US$) in Heavily indebted poor countries and Imports (BoP, current US$) in St. Vincent and the Grenadines?
Provide a short and direct response. 8.84e+1. In the year 2005, what is the difference between the Imports (BoP, current US$) in China and Imports (BoP, current US$) in French Polynesia?
Give a very brief answer. 6.44e+11. In the year 2005, what is the difference between the Imports (BoP, current US$) in China and Imports (BoP, current US$) in St. Vincent and the Grenadines?
Your answer should be compact. 6.46e+11. In the year 2005, what is the difference between the Imports (BoP, current US$) of French Polynesia and Imports (BoP, current US$) of St. Vincent and the Grenadines?
Your answer should be compact. 2.02e+09. In the year 2006, what is the difference between the Imports (BoP, current US$) in Heavily indebted poor countries and Imports (BoP, current US$) in China?
Your answer should be very brief. -6.60e+11. In the year 2006, what is the difference between the Imports (BoP, current US$) of Heavily indebted poor countries and Imports (BoP, current US$) of French Polynesia?
Ensure brevity in your answer.  1.02e+11. In the year 2006, what is the difference between the Imports (BoP, current US$) of Heavily indebted poor countries and Imports (BoP, current US$) of St. Vincent and the Grenadines?
Offer a very short reply. 1.04e+11. In the year 2006, what is the difference between the Imports (BoP, current US$) of China and Imports (BoP, current US$) of French Polynesia?
Ensure brevity in your answer.  7.62e+11. In the year 2006, what is the difference between the Imports (BoP, current US$) of China and Imports (BoP, current US$) of St. Vincent and the Grenadines?
Your response must be concise. 7.64e+11. In the year 2006, what is the difference between the Imports (BoP, current US$) in French Polynesia and Imports (BoP, current US$) in St. Vincent and the Grenadines?
Keep it short and to the point. 1.83e+09. In the year 2007, what is the difference between the Imports (BoP, current US$) in Heavily indebted poor countries and Imports (BoP, current US$) in China?
Your answer should be compact. -8.17e+11. In the year 2007, what is the difference between the Imports (BoP, current US$) in Heavily indebted poor countries and Imports (BoP, current US$) in French Polynesia?
Offer a very short reply. 1.28e+11. In the year 2007, what is the difference between the Imports (BoP, current US$) in Heavily indebted poor countries and Imports (BoP, current US$) in St. Vincent and the Grenadines?
Give a very brief answer. 1.30e+11. In the year 2007, what is the difference between the Imports (BoP, current US$) in China and Imports (BoP, current US$) in French Polynesia?
Keep it short and to the point. 9.45e+11. In the year 2007, what is the difference between the Imports (BoP, current US$) of China and Imports (BoP, current US$) of St. Vincent and the Grenadines?
Your answer should be very brief. 9.47e+11. In the year 2007, what is the difference between the Imports (BoP, current US$) in French Polynesia and Imports (BoP, current US$) in St. Vincent and the Grenadines?
Offer a very short reply. 2.03e+09. In the year 2008, what is the difference between the Imports (BoP, current US$) in Heavily indebted poor countries and Imports (BoP, current US$) in China?
Keep it short and to the point. -9.81e+11. In the year 2008, what is the difference between the Imports (BoP, current US$) in Heavily indebted poor countries and Imports (BoP, current US$) in French Polynesia?
Your response must be concise. 1.61e+11. In the year 2008, what is the difference between the Imports (BoP, current US$) in Heavily indebted poor countries and Imports (BoP, current US$) in St. Vincent and the Grenadines?
Offer a terse response. 1.63e+11. In the year 2008, what is the difference between the Imports (BoP, current US$) in China and Imports (BoP, current US$) in French Polynesia?
Ensure brevity in your answer.  1.14e+12. In the year 2008, what is the difference between the Imports (BoP, current US$) of China and Imports (BoP, current US$) of St. Vincent and the Grenadines?
Provide a short and direct response. 1.14e+12. In the year 2008, what is the difference between the Imports (BoP, current US$) in French Polynesia and Imports (BoP, current US$) in St. Vincent and the Grenadines?
Offer a very short reply. 2.43e+09. In the year 2009, what is the difference between the Imports (BoP, current US$) of Heavily indebted poor countries and Imports (BoP, current US$) of China?
Provide a short and direct response. -8.95e+11. In the year 2009, what is the difference between the Imports (BoP, current US$) in Heavily indebted poor countries and Imports (BoP, current US$) in French Polynesia?
Make the answer very short. 1.43e+11. In the year 2009, what is the difference between the Imports (BoP, current US$) in Heavily indebted poor countries and Imports (BoP, current US$) in St. Vincent and the Grenadines?
Keep it short and to the point. 1.45e+11. In the year 2009, what is the difference between the Imports (BoP, current US$) in China and Imports (BoP, current US$) in French Polynesia?
Give a very brief answer. 1.04e+12. In the year 2009, what is the difference between the Imports (BoP, current US$) in China and Imports (BoP, current US$) in St. Vincent and the Grenadines?
Provide a succinct answer. 1.04e+12. In the year 2009, what is the difference between the Imports (BoP, current US$) of French Polynesia and Imports (BoP, current US$) of St. Vincent and the Grenadines?
Provide a succinct answer. 1.99e+09. In the year 2010, what is the difference between the Imports (BoP, current US$) in Heavily indebted poor countries and Imports (BoP, current US$) in China?
Provide a succinct answer. -1.25e+12. In the year 2010, what is the difference between the Imports (BoP, current US$) in Heavily indebted poor countries and Imports (BoP, current US$) in French Polynesia?
Your response must be concise. 1.70e+11. In the year 2010, what is the difference between the Imports (BoP, current US$) of Heavily indebted poor countries and Imports (BoP, current US$) of St. Vincent and the Grenadines?
Give a very brief answer. 1.71e+11. In the year 2010, what is the difference between the Imports (BoP, current US$) of China and Imports (BoP, current US$) of French Polynesia?
Your answer should be very brief. 1.42e+12. In the year 2010, what is the difference between the Imports (BoP, current US$) in China and Imports (BoP, current US$) in St. Vincent and the Grenadines?
Your response must be concise. 1.42e+12. In the year 2010, what is the difference between the Imports (BoP, current US$) of French Polynesia and Imports (BoP, current US$) of St. Vincent and the Grenadines?
Your answer should be very brief. 1.94e+09. In the year 2011, what is the difference between the Imports (BoP, current US$) in Heavily indebted poor countries and Imports (BoP, current US$) in China?
Your answer should be compact. -1.60e+12. In the year 2011, what is the difference between the Imports (BoP, current US$) of Heavily indebted poor countries and Imports (BoP, current US$) of French Polynesia?
Your answer should be compact. 2.07e+11. In the year 2011, what is the difference between the Imports (BoP, current US$) of Heavily indebted poor countries and Imports (BoP, current US$) of St. Vincent and the Grenadines?
Make the answer very short. 2.09e+11. In the year 2011, what is the difference between the Imports (BoP, current US$) of China and Imports (BoP, current US$) of French Polynesia?
Your answer should be very brief. 1.81e+12. In the year 2011, what is the difference between the Imports (BoP, current US$) of China and Imports (BoP, current US$) of St. Vincent and the Grenadines?
Make the answer very short. 1.81e+12. In the year 2011, what is the difference between the Imports (BoP, current US$) of French Polynesia and Imports (BoP, current US$) of St. Vincent and the Grenadines?
Keep it short and to the point. 1.96e+09. In the year 2012, what is the difference between the Imports (BoP, current US$) of Heavily indebted poor countries and Imports (BoP, current US$) of China?
Offer a terse response. -1.73e+12. In the year 2012, what is the difference between the Imports (BoP, current US$) of Heavily indebted poor countries and Imports (BoP, current US$) of French Polynesia?
Offer a terse response. 2.29e+11. In the year 2012, what is the difference between the Imports (BoP, current US$) in Heavily indebted poor countries and Imports (BoP, current US$) in St. Vincent and the Grenadines?
Offer a terse response. 2.31e+11. In the year 2012, what is the difference between the Imports (BoP, current US$) of China and Imports (BoP, current US$) of French Polynesia?
Ensure brevity in your answer.  1.95e+12. In the year 2012, what is the difference between the Imports (BoP, current US$) of China and Imports (BoP, current US$) of St. Vincent and the Grenadines?
Keep it short and to the point. 1.96e+12. In the year 2012, what is the difference between the Imports (BoP, current US$) in French Polynesia and Imports (BoP, current US$) in St. Vincent and the Grenadines?
Keep it short and to the point. 1.80e+09. What is the ratio of the Imports (BoP, current US$) in Heavily indebted poor countries in 2005 to that in 2006?
Your answer should be very brief. 0.85. What is the ratio of the Imports (BoP, current US$) of China in 2005 to that in 2006?
Make the answer very short. 0.84. What is the ratio of the Imports (BoP, current US$) in French Polynesia in 2005 to that in 2006?
Provide a succinct answer. 1.07. What is the ratio of the Imports (BoP, current US$) of St. Vincent and the Grenadines in 2005 to that in 2006?
Your answer should be compact. 0.89. What is the ratio of the Imports (BoP, current US$) of Heavily indebted poor countries in 2005 to that in 2007?
Provide a short and direct response. 0.68. What is the ratio of the Imports (BoP, current US$) in China in 2005 to that in 2007?
Offer a terse response. 0.68. What is the ratio of the Imports (BoP, current US$) in French Polynesia in 2005 to that in 2007?
Provide a succinct answer. 0.95. What is the ratio of the Imports (BoP, current US$) of St. Vincent and the Grenadines in 2005 to that in 2007?
Provide a succinct answer. 0.72. What is the ratio of the Imports (BoP, current US$) in Heavily indebted poor countries in 2005 to that in 2008?
Offer a terse response. 0.54. What is the ratio of the Imports (BoP, current US$) in China in 2005 to that in 2008?
Provide a short and direct response. 0.56. What is the ratio of the Imports (BoP, current US$) of French Polynesia in 2005 to that in 2008?
Make the answer very short. 0.81. What is the ratio of the Imports (BoP, current US$) of St. Vincent and the Grenadines in 2005 to that in 2008?
Your response must be concise. 0.68. What is the ratio of the Imports (BoP, current US$) in Heavily indebted poor countries in 2005 to that in 2009?
Offer a very short reply. 0.61. What is the ratio of the Imports (BoP, current US$) in China in 2005 to that in 2009?
Provide a succinct answer. 0.62. What is the ratio of the Imports (BoP, current US$) in French Polynesia in 2005 to that in 2009?
Ensure brevity in your answer.  0.97. What is the ratio of the Imports (BoP, current US$) of St. Vincent and the Grenadines in 2005 to that in 2009?
Ensure brevity in your answer.  0.75. What is the ratio of the Imports (BoP, current US$) in Heavily indebted poor countries in 2005 to that in 2010?
Your answer should be very brief. 0.52. What is the ratio of the Imports (BoP, current US$) in China in 2005 to that in 2010?
Give a very brief answer. 0.45. What is the ratio of the Imports (BoP, current US$) of St. Vincent and the Grenadines in 2005 to that in 2010?
Ensure brevity in your answer.  0.75. What is the ratio of the Imports (BoP, current US$) of Heavily indebted poor countries in 2005 to that in 2011?
Provide a succinct answer. 0.42. What is the ratio of the Imports (BoP, current US$) of China in 2005 to that in 2011?
Make the answer very short. 0.36. What is the ratio of the Imports (BoP, current US$) in French Polynesia in 2005 to that in 2011?
Offer a very short reply. 0.99. What is the ratio of the Imports (BoP, current US$) in St. Vincent and the Grenadines in 2005 to that in 2011?
Offer a terse response. 0.77. What is the ratio of the Imports (BoP, current US$) in Heavily indebted poor countries in 2005 to that in 2012?
Keep it short and to the point. 0.38. What is the ratio of the Imports (BoP, current US$) in China in 2005 to that in 2012?
Ensure brevity in your answer.  0.33. What is the ratio of the Imports (BoP, current US$) of French Polynesia in 2005 to that in 2012?
Offer a terse response. 1.05. What is the ratio of the Imports (BoP, current US$) of St. Vincent and the Grenadines in 2005 to that in 2012?
Ensure brevity in your answer.  0.72. What is the ratio of the Imports (BoP, current US$) of Heavily indebted poor countries in 2006 to that in 2007?
Offer a terse response. 0.8. What is the ratio of the Imports (BoP, current US$) in China in 2006 to that in 2007?
Your answer should be very brief. 0.81. What is the ratio of the Imports (BoP, current US$) in French Polynesia in 2006 to that in 2007?
Your answer should be compact. 0.89. What is the ratio of the Imports (BoP, current US$) in St. Vincent and the Grenadines in 2006 to that in 2007?
Offer a very short reply. 0.81. What is the ratio of the Imports (BoP, current US$) of Heavily indebted poor countries in 2006 to that in 2008?
Offer a terse response. 0.64. What is the ratio of the Imports (BoP, current US$) of China in 2006 to that in 2008?
Keep it short and to the point. 0.67. What is the ratio of the Imports (BoP, current US$) in French Polynesia in 2006 to that in 2008?
Offer a very short reply. 0.75. What is the ratio of the Imports (BoP, current US$) in St. Vincent and the Grenadines in 2006 to that in 2008?
Your response must be concise. 0.76. What is the ratio of the Imports (BoP, current US$) of Heavily indebted poor countries in 2006 to that in 2009?
Provide a succinct answer. 0.72. What is the ratio of the Imports (BoP, current US$) of China in 2006 to that in 2009?
Offer a very short reply. 0.73. What is the ratio of the Imports (BoP, current US$) of French Polynesia in 2006 to that in 2009?
Your response must be concise. 0.91. What is the ratio of the Imports (BoP, current US$) in St. Vincent and the Grenadines in 2006 to that in 2009?
Offer a very short reply. 0.84. What is the ratio of the Imports (BoP, current US$) in Heavily indebted poor countries in 2006 to that in 2010?
Your answer should be compact. 0.61. What is the ratio of the Imports (BoP, current US$) of China in 2006 to that in 2010?
Your answer should be compact. 0.54. What is the ratio of the Imports (BoP, current US$) of French Polynesia in 2006 to that in 2010?
Offer a very short reply. 0.93. What is the ratio of the Imports (BoP, current US$) of St. Vincent and the Grenadines in 2006 to that in 2010?
Make the answer very short. 0.84. What is the ratio of the Imports (BoP, current US$) of Heavily indebted poor countries in 2006 to that in 2011?
Offer a terse response. 0.5. What is the ratio of the Imports (BoP, current US$) in China in 2006 to that in 2011?
Your answer should be very brief. 0.42. What is the ratio of the Imports (BoP, current US$) in French Polynesia in 2006 to that in 2011?
Your response must be concise. 0.92. What is the ratio of the Imports (BoP, current US$) of St. Vincent and the Grenadines in 2006 to that in 2011?
Make the answer very short. 0.87. What is the ratio of the Imports (BoP, current US$) in Heavily indebted poor countries in 2006 to that in 2012?
Offer a terse response. 0.45. What is the ratio of the Imports (BoP, current US$) in China in 2006 to that in 2012?
Keep it short and to the point. 0.39. What is the ratio of the Imports (BoP, current US$) of French Polynesia in 2006 to that in 2012?
Offer a terse response. 0.98. What is the ratio of the Imports (BoP, current US$) of St. Vincent and the Grenadines in 2006 to that in 2012?
Your answer should be very brief. 0.81. What is the ratio of the Imports (BoP, current US$) of Heavily indebted poor countries in 2007 to that in 2008?
Make the answer very short. 0.79. What is the ratio of the Imports (BoP, current US$) of China in 2007 to that in 2008?
Offer a very short reply. 0.83. What is the ratio of the Imports (BoP, current US$) in French Polynesia in 2007 to that in 2008?
Your response must be concise. 0.85. What is the ratio of the Imports (BoP, current US$) of St. Vincent and the Grenadines in 2007 to that in 2008?
Your answer should be compact. 0.93. What is the ratio of the Imports (BoP, current US$) of Heavily indebted poor countries in 2007 to that in 2009?
Your response must be concise. 0.89. What is the ratio of the Imports (BoP, current US$) in China in 2007 to that in 2009?
Offer a terse response. 0.91. What is the ratio of the Imports (BoP, current US$) of French Polynesia in 2007 to that in 2009?
Give a very brief answer. 1.02. What is the ratio of the Imports (BoP, current US$) of St. Vincent and the Grenadines in 2007 to that in 2009?
Provide a succinct answer. 1.04. What is the ratio of the Imports (BoP, current US$) of Heavily indebted poor countries in 2007 to that in 2010?
Give a very brief answer. 0.76. What is the ratio of the Imports (BoP, current US$) in China in 2007 to that in 2010?
Give a very brief answer. 0.66. What is the ratio of the Imports (BoP, current US$) in French Polynesia in 2007 to that in 2010?
Give a very brief answer. 1.04. What is the ratio of the Imports (BoP, current US$) of St. Vincent and the Grenadines in 2007 to that in 2010?
Give a very brief answer. 1.03. What is the ratio of the Imports (BoP, current US$) in Heavily indebted poor countries in 2007 to that in 2011?
Provide a short and direct response. 0.62. What is the ratio of the Imports (BoP, current US$) of China in 2007 to that in 2011?
Offer a terse response. 0.52. What is the ratio of the Imports (BoP, current US$) of French Polynesia in 2007 to that in 2011?
Provide a succinct answer. 1.04. What is the ratio of the Imports (BoP, current US$) in St. Vincent and the Grenadines in 2007 to that in 2011?
Ensure brevity in your answer.  1.07. What is the ratio of the Imports (BoP, current US$) of Heavily indebted poor countries in 2007 to that in 2012?
Your answer should be very brief. 0.56. What is the ratio of the Imports (BoP, current US$) of China in 2007 to that in 2012?
Give a very brief answer. 0.48. What is the ratio of the Imports (BoP, current US$) of French Polynesia in 2007 to that in 2012?
Your response must be concise. 1.1. What is the ratio of the Imports (BoP, current US$) of Heavily indebted poor countries in 2008 to that in 2009?
Your response must be concise. 1.13. What is the ratio of the Imports (BoP, current US$) of China in 2008 to that in 2009?
Offer a very short reply. 1.1. What is the ratio of the Imports (BoP, current US$) in French Polynesia in 2008 to that in 2009?
Offer a very short reply. 1.21. What is the ratio of the Imports (BoP, current US$) in St. Vincent and the Grenadines in 2008 to that in 2009?
Provide a short and direct response. 1.11. What is the ratio of the Imports (BoP, current US$) of Heavily indebted poor countries in 2008 to that in 2010?
Make the answer very short. 0.95. What is the ratio of the Imports (BoP, current US$) in China in 2008 to that in 2010?
Keep it short and to the point. 0.8. What is the ratio of the Imports (BoP, current US$) of French Polynesia in 2008 to that in 2010?
Make the answer very short. 1.23. What is the ratio of the Imports (BoP, current US$) in St. Vincent and the Grenadines in 2008 to that in 2010?
Provide a succinct answer. 1.11. What is the ratio of the Imports (BoP, current US$) in Heavily indebted poor countries in 2008 to that in 2011?
Keep it short and to the point. 0.78. What is the ratio of the Imports (BoP, current US$) in China in 2008 to that in 2011?
Give a very brief answer. 0.63. What is the ratio of the Imports (BoP, current US$) of French Polynesia in 2008 to that in 2011?
Make the answer very short. 1.23. What is the ratio of the Imports (BoP, current US$) in St. Vincent and the Grenadines in 2008 to that in 2011?
Provide a short and direct response. 1.14. What is the ratio of the Imports (BoP, current US$) of Heavily indebted poor countries in 2008 to that in 2012?
Offer a very short reply. 0.71. What is the ratio of the Imports (BoP, current US$) of China in 2008 to that in 2012?
Provide a short and direct response. 0.59. What is the ratio of the Imports (BoP, current US$) of French Polynesia in 2008 to that in 2012?
Offer a terse response. 1.3. What is the ratio of the Imports (BoP, current US$) in St. Vincent and the Grenadines in 2008 to that in 2012?
Provide a short and direct response. 1.07. What is the ratio of the Imports (BoP, current US$) of Heavily indebted poor countries in 2009 to that in 2010?
Offer a terse response. 0.85. What is the ratio of the Imports (BoP, current US$) in China in 2009 to that in 2010?
Provide a short and direct response. 0.73. What is the ratio of the Imports (BoP, current US$) in French Polynesia in 2009 to that in 2010?
Provide a succinct answer. 1.02. What is the ratio of the Imports (BoP, current US$) of St. Vincent and the Grenadines in 2009 to that in 2010?
Your response must be concise. 1. What is the ratio of the Imports (BoP, current US$) in Heavily indebted poor countries in 2009 to that in 2011?
Offer a very short reply. 0.7. What is the ratio of the Imports (BoP, current US$) of China in 2009 to that in 2011?
Give a very brief answer. 0.58. What is the ratio of the Imports (BoP, current US$) in St. Vincent and the Grenadines in 2009 to that in 2011?
Provide a short and direct response. 1.03. What is the ratio of the Imports (BoP, current US$) in Heavily indebted poor countries in 2009 to that in 2012?
Provide a short and direct response. 0.63. What is the ratio of the Imports (BoP, current US$) in China in 2009 to that in 2012?
Offer a terse response. 0.53. What is the ratio of the Imports (BoP, current US$) in French Polynesia in 2009 to that in 2012?
Your response must be concise. 1.08. What is the ratio of the Imports (BoP, current US$) of Heavily indebted poor countries in 2010 to that in 2011?
Offer a very short reply. 0.82. What is the ratio of the Imports (BoP, current US$) of China in 2010 to that in 2011?
Offer a terse response. 0.79. What is the ratio of the Imports (BoP, current US$) in Heavily indebted poor countries in 2010 to that in 2012?
Keep it short and to the point. 0.74. What is the ratio of the Imports (BoP, current US$) of China in 2010 to that in 2012?
Provide a succinct answer. 0.73. What is the ratio of the Imports (BoP, current US$) of French Polynesia in 2010 to that in 2012?
Make the answer very short. 1.06. What is the ratio of the Imports (BoP, current US$) in St. Vincent and the Grenadines in 2010 to that in 2012?
Give a very brief answer. 0.97. What is the ratio of the Imports (BoP, current US$) in Heavily indebted poor countries in 2011 to that in 2012?
Offer a very short reply. 0.9. What is the ratio of the Imports (BoP, current US$) of China in 2011 to that in 2012?
Your answer should be compact. 0.92. What is the ratio of the Imports (BoP, current US$) of French Polynesia in 2011 to that in 2012?
Provide a short and direct response. 1.06. What is the ratio of the Imports (BoP, current US$) in St. Vincent and the Grenadines in 2011 to that in 2012?
Provide a short and direct response. 0.94. What is the difference between the highest and the second highest Imports (BoP, current US$) of Heavily indebted poor countries?
Offer a very short reply. 2.20e+1. What is the difference between the highest and the second highest Imports (BoP, current US$) of China?
Keep it short and to the point. 1.48e+11. What is the difference between the highest and the second highest Imports (BoP, current US$) of French Polynesia?
Provide a short and direct response. 4.33e+08. What is the difference between the highest and the second highest Imports (BoP, current US$) of St. Vincent and the Grenadines?
Offer a very short reply. 2.87e+07. What is the difference between the highest and the lowest Imports (BoP, current US$) in Heavily indebted poor countries?
Your answer should be very brief. 1.42e+11. What is the difference between the highest and the lowest Imports (BoP, current US$) of China?
Provide a short and direct response. 1.31e+12. What is the difference between the highest and the lowest Imports (BoP, current US$) in French Polynesia?
Make the answer very short. 7.10e+08. What is the difference between the highest and the lowest Imports (BoP, current US$) of St. Vincent and the Grenadines?
Your response must be concise. 1.40e+08. 